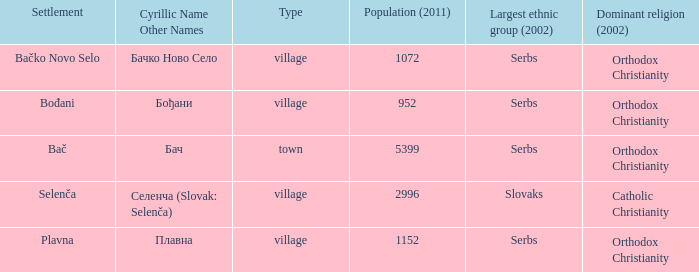What is the second way of writting плавна. Plavna. 